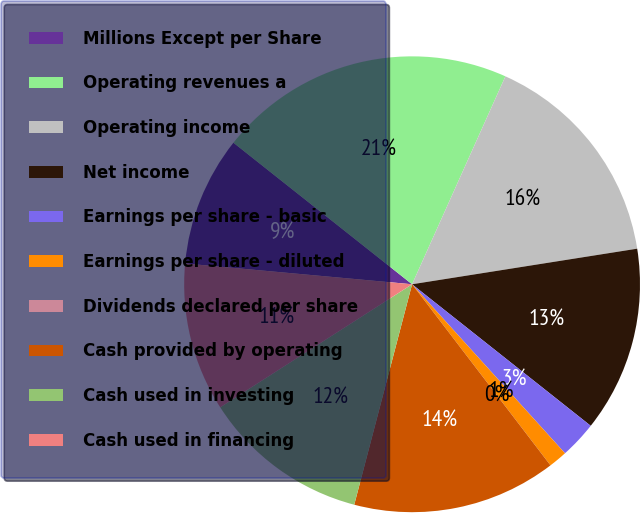Convert chart to OTSL. <chart><loc_0><loc_0><loc_500><loc_500><pie_chart><fcel>Millions Except per Share<fcel>Operating revenues a<fcel>Operating income<fcel>Net income<fcel>Earnings per share - basic<fcel>Earnings per share - diluted<fcel>Dividends declared per share<fcel>Cash provided by operating<fcel>Cash used in investing<fcel>Cash used in financing<nl><fcel>9.21%<fcel>21.05%<fcel>15.79%<fcel>13.16%<fcel>2.63%<fcel>1.32%<fcel>0.0%<fcel>14.47%<fcel>11.84%<fcel>10.53%<nl></chart> 